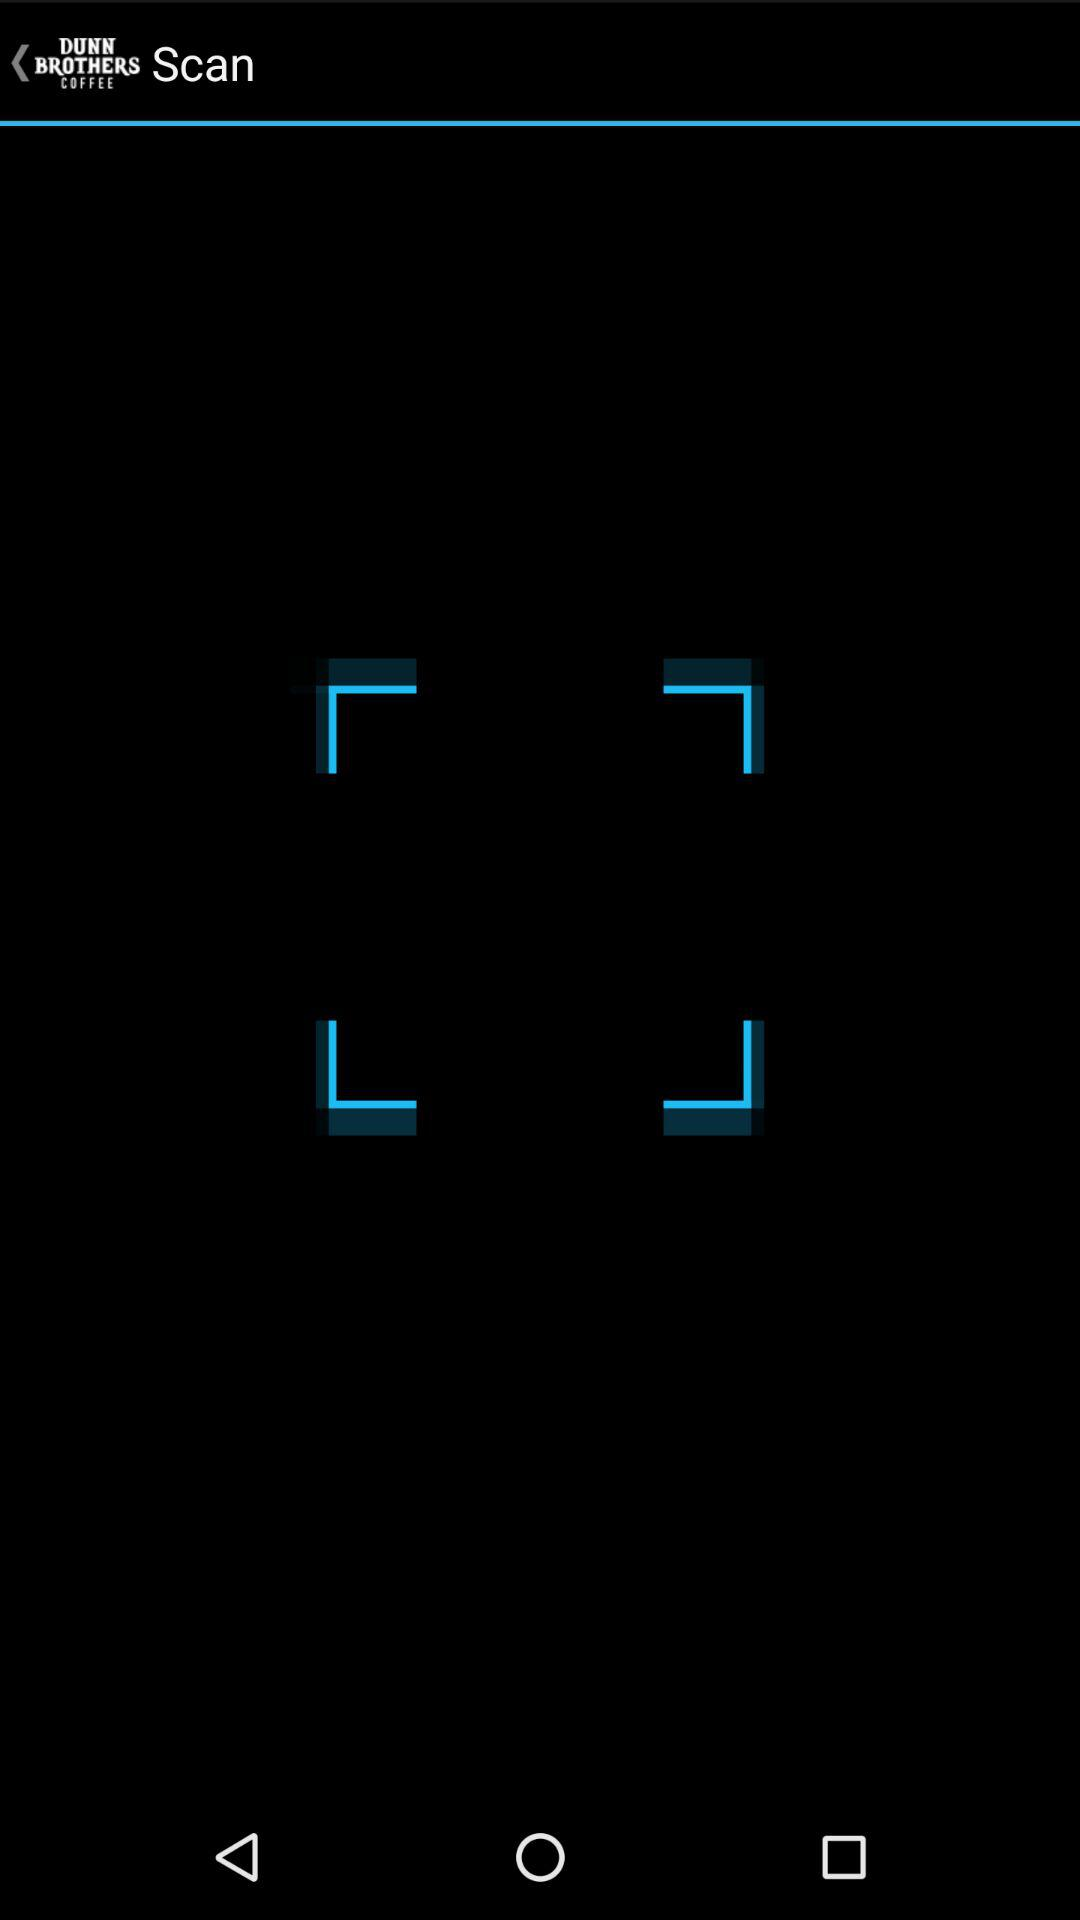What is the name of the application? The name of the application is "DUNN BROTHERS COFFEE". 